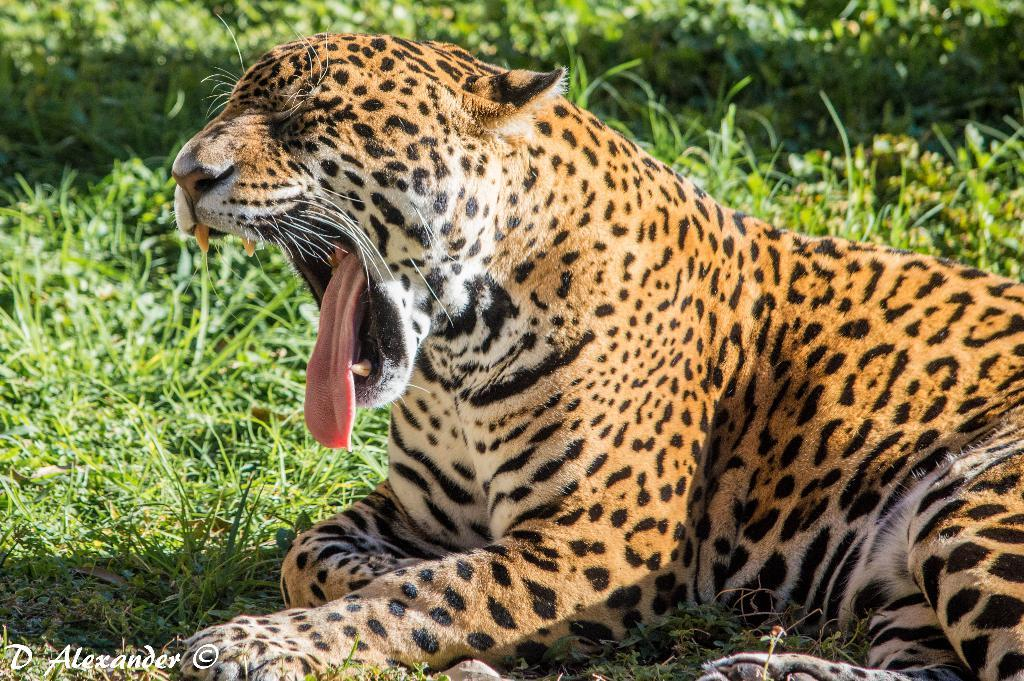What animal is present in the image? There is a jaguar in the image. What is the jaguar doing in the image? The jaguar is yawning in the image. Where is the jaguar located in the image? The jaguar is sitting on a grass field in the image. How many beads are being held by the baby jaguar in the image? There is no baby jaguar or beads present in the image. 